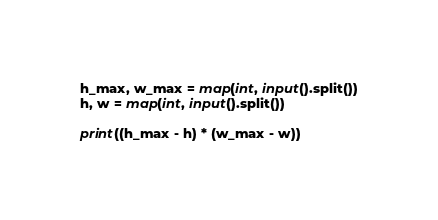<code> <loc_0><loc_0><loc_500><loc_500><_Python_>h_max, w_max = map(int, input().split())
h, w = map(int, input().split())

print((h_max - h) * (w_max - w))
</code> 